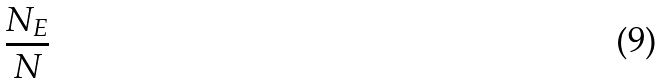Convert formula to latex. <formula><loc_0><loc_0><loc_500><loc_500>\frac { N _ { E } } { N }</formula> 